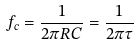Convert formula to latex. <formula><loc_0><loc_0><loc_500><loc_500>f _ { c } = \frac { 1 } { 2 \pi R C } = \frac { 1 } { 2 \pi \tau }</formula> 